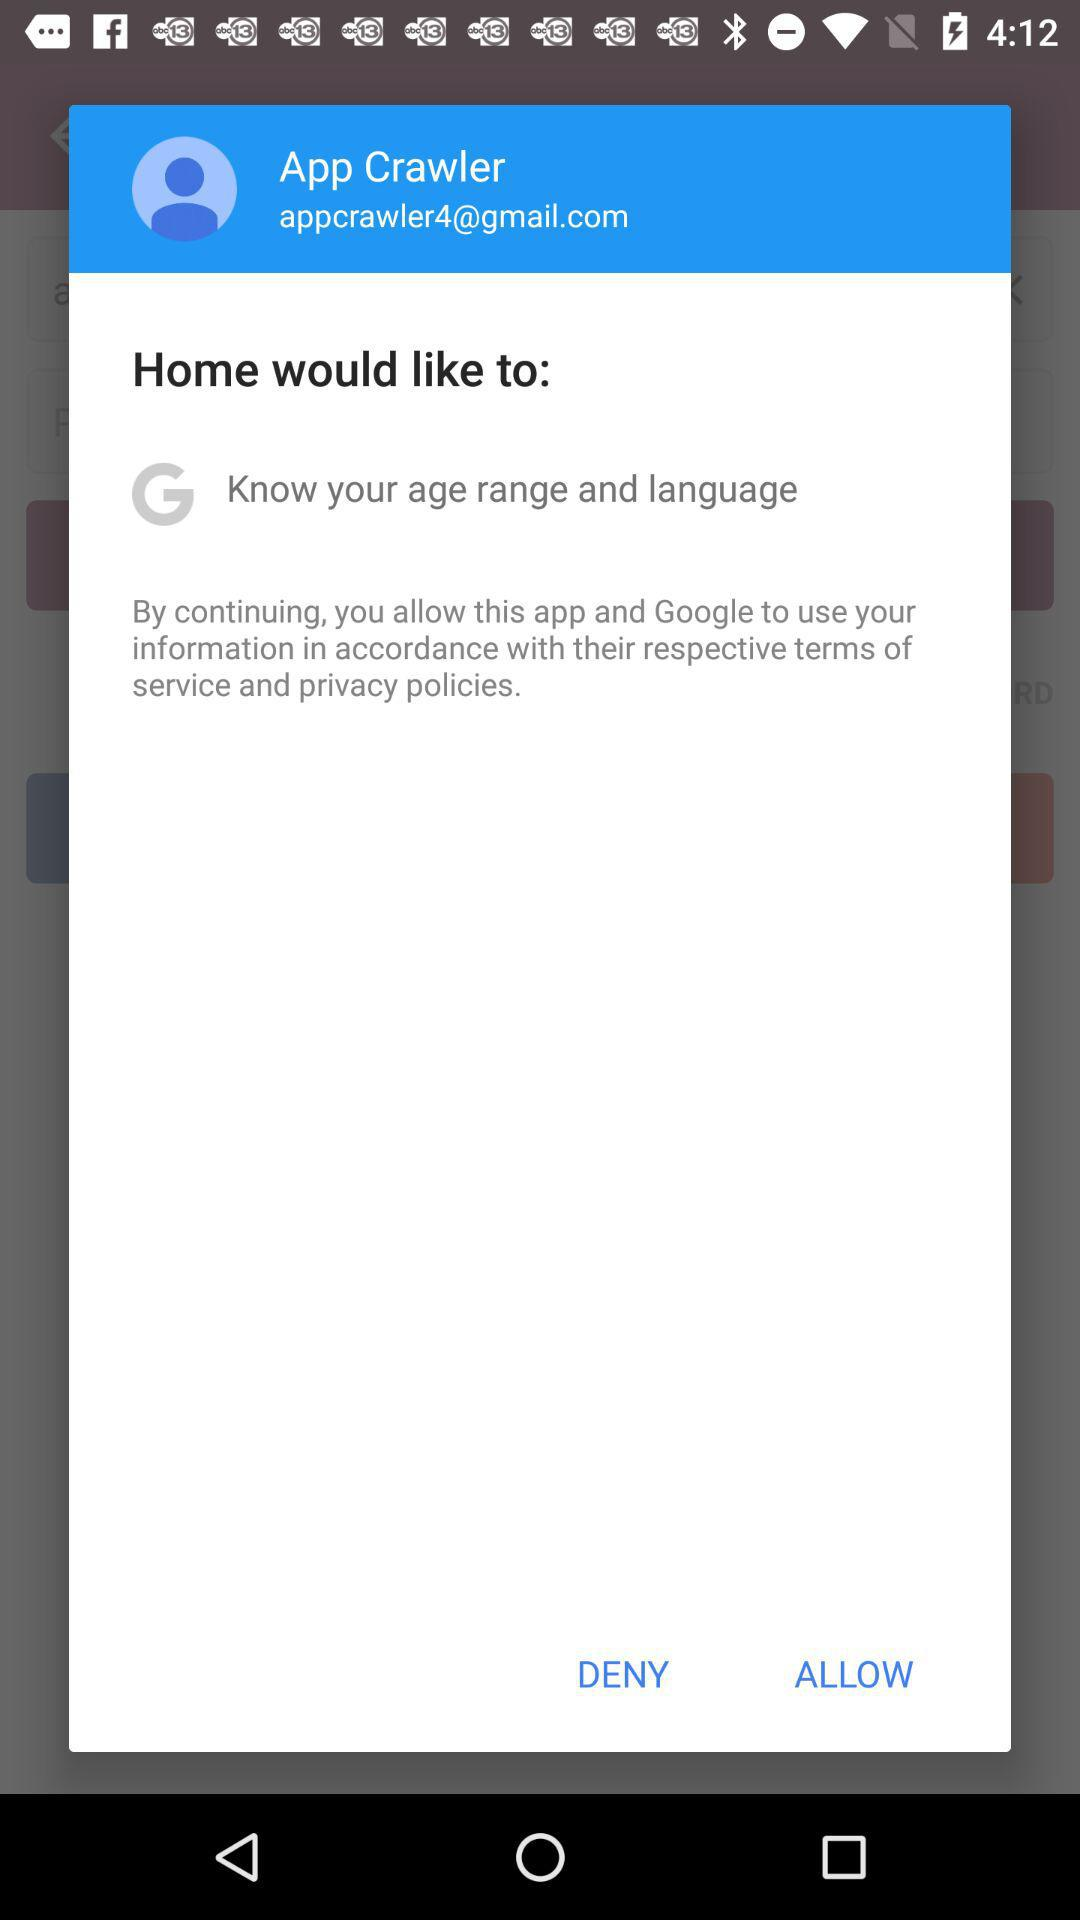What Gmail address is used? The used Gmail address is appcrawler4@gmail.com. 